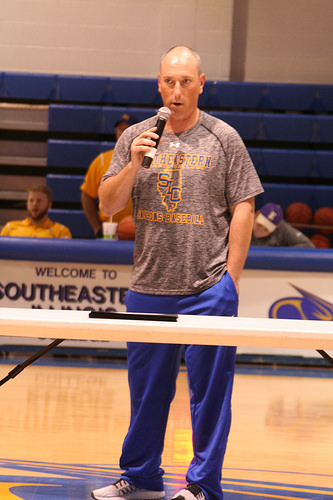<image>
Is the ball behind the microphone? Yes. From this viewpoint, the ball is positioned behind the microphone, with the microphone partially or fully occluding the ball. Is there a bleachers behind the man? Yes. From this viewpoint, the bleachers is positioned behind the man, with the man partially or fully occluding the bleachers. 